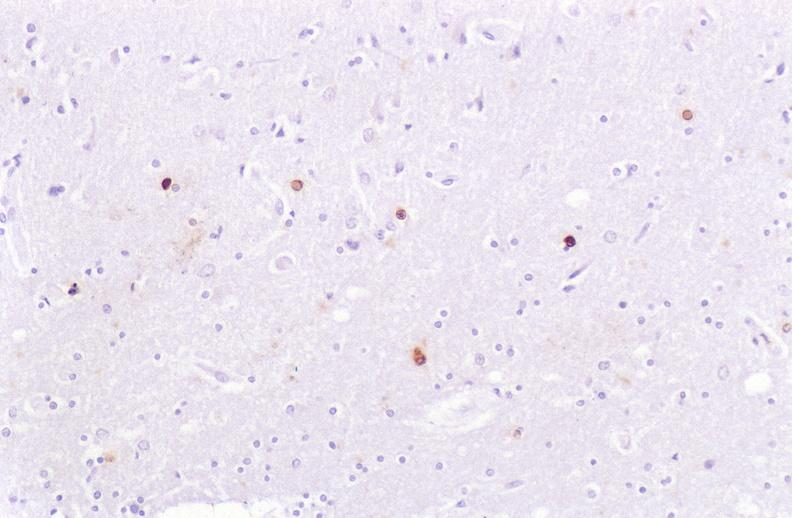s situs inversus present?
Answer the question using a single word or phrase. No 